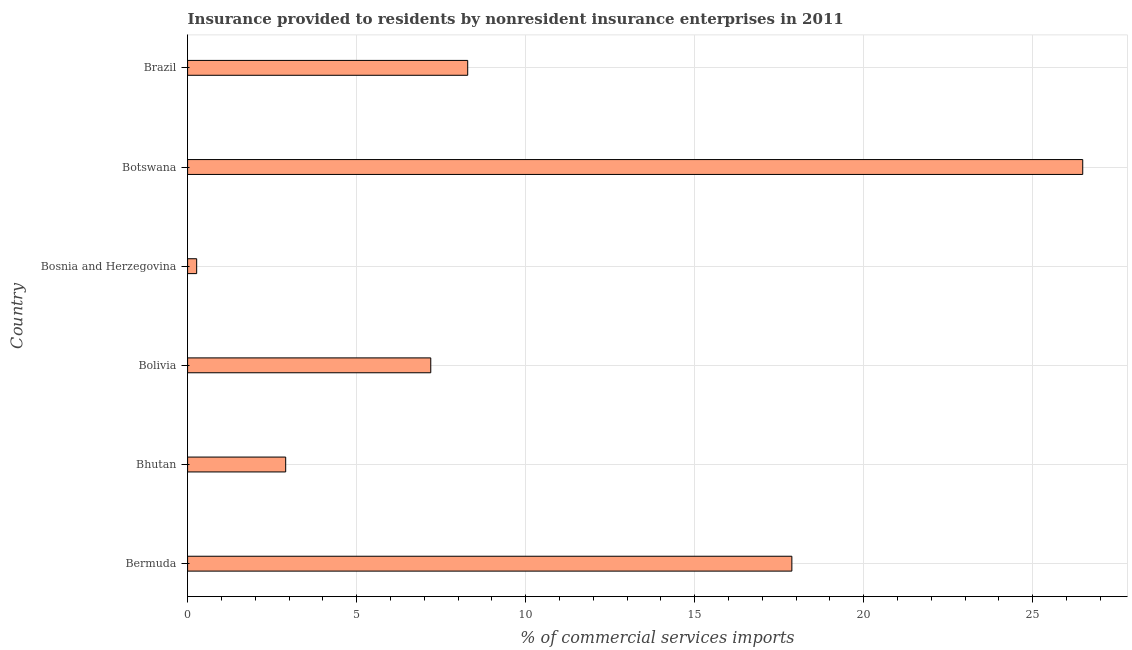Does the graph contain grids?
Your response must be concise. Yes. What is the title of the graph?
Offer a very short reply. Insurance provided to residents by nonresident insurance enterprises in 2011. What is the label or title of the X-axis?
Provide a succinct answer. % of commercial services imports. What is the label or title of the Y-axis?
Offer a terse response. Country. What is the insurance provided by non-residents in Bolivia?
Ensure brevity in your answer.  7.19. Across all countries, what is the maximum insurance provided by non-residents?
Offer a very short reply. 26.48. Across all countries, what is the minimum insurance provided by non-residents?
Make the answer very short. 0.27. In which country was the insurance provided by non-residents maximum?
Your response must be concise. Botswana. In which country was the insurance provided by non-residents minimum?
Ensure brevity in your answer.  Bosnia and Herzegovina. What is the sum of the insurance provided by non-residents?
Give a very brief answer. 63.01. What is the difference between the insurance provided by non-residents in Bhutan and Brazil?
Offer a terse response. -5.38. What is the average insurance provided by non-residents per country?
Your response must be concise. 10.5. What is the median insurance provided by non-residents?
Your answer should be compact. 7.74. In how many countries, is the insurance provided by non-residents greater than 18 %?
Offer a terse response. 1. What is the ratio of the insurance provided by non-residents in Bhutan to that in Brazil?
Give a very brief answer. 0.35. Is the difference between the insurance provided by non-residents in Bosnia and Herzegovina and Botswana greater than the difference between any two countries?
Keep it short and to the point. Yes. What is the difference between the highest and the second highest insurance provided by non-residents?
Make the answer very short. 8.61. What is the difference between the highest and the lowest insurance provided by non-residents?
Keep it short and to the point. 26.21. In how many countries, is the insurance provided by non-residents greater than the average insurance provided by non-residents taken over all countries?
Ensure brevity in your answer.  2. What is the % of commercial services imports in Bermuda?
Provide a short and direct response. 17.88. What is the % of commercial services imports of Bhutan?
Offer a very short reply. 2.9. What is the % of commercial services imports in Bolivia?
Provide a succinct answer. 7.19. What is the % of commercial services imports of Bosnia and Herzegovina?
Keep it short and to the point. 0.27. What is the % of commercial services imports in Botswana?
Offer a very short reply. 26.48. What is the % of commercial services imports of Brazil?
Ensure brevity in your answer.  8.29. What is the difference between the % of commercial services imports in Bermuda and Bhutan?
Your response must be concise. 14.98. What is the difference between the % of commercial services imports in Bermuda and Bolivia?
Ensure brevity in your answer.  10.68. What is the difference between the % of commercial services imports in Bermuda and Bosnia and Herzegovina?
Offer a very short reply. 17.61. What is the difference between the % of commercial services imports in Bermuda and Botswana?
Offer a terse response. -8.61. What is the difference between the % of commercial services imports in Bermuda and Brazil?
Keep it short and to the point. 9.59. What is the difference between the % of commercial services imports in Bhutan and Bolivia?
Ensure brevity in your answer.  -4.29. What is the difference between the % of commercial services imports in Bhutan and Bosnia and Herzegovina?
Keep it short and to the point. 2.63. What is the difference between the % of commercial services imports in Bhutan and Botswana?
Keep it short and to the point. -23.58. What is the difference between the % of commercial services imports in Bhutan and Brazil?
Give a very brief answer. -5.39. What is the difference between the % of commercial services imports in Bolivia and Bosnia and Herzegovina?
Provide a short and direct response. 6.93. What is the difference between the % of commercial services imports in Bolivia and Botswana?
Offer a terse response. -19.29. What is the difference between the % of commercial services imports in Bolivia and Brazil?
Your answer should be very brief. -1.09. What is the difference between the % of commercial services imports in Bosnia and Herzegovina and Botswana?
Your answer should be very brief. -26.21. What is the difference between the % of commercial services imports in Bosnia and Herzegovina and Brazil?
Your answer should be compact. -8.02. What is the difference between the % of commercial services imports in Botswana and Brazil?
Your response must be concise. 18.2. What is the ratio of the % of commercial services imports in Bermuda to that in Bhutan?
Provide a succinct answer. 6.16. What is the ratio of the % of commercial services imports in Bermuda to that in Bolivia?
Keep it short and to the point. 2.48. What is the ratio of the % of commercial services imports in Bermuda to that in Bosnia and Herzegovina?
Provide a succinct answer. 66.53. What is the ratio of the % of commercial services imports in Bermuda to that in Botswana?
Your answer should be compact. 0.68. What is the ratio of the % of commercial services imports in Bermuda to that in Brazil?
Provide a succinct answer. 2.16. What is the ratio of the % of commercial services imports in Bhutan to that in Bolivia?
Keep it short and to the point. 0.4. What is the ratio of the % of commercial services imports in Bhutan to that in Bosnia and Herzegovina?
Your response must be concise. 10.8. What is the ratio of the % of commercial services imports in Bhutan to that in Botswana?
Make the answer very short. 0.11. What is the ratio of the % of commercial services imports in Bhutan to that in Brazil?
Offer a very short reply. 0.35. What is the ratio of the % of commercial services imports in Bolivia to that in Bosnia and Herzegovina?
Ensure brevity in your answer.  26.77. What is the ratio of the % of commercial services imports in Bolivia to that in Botswana?
Make the answer very short. 0.27. What is the ratio of the % of commercial services imports in Bolivia to that in Brazil?
Give a very brief answer. 0.87. What is the ratio of the % of commercial services imports in Bosnia and Herzegovina to that in Botswana?
Your answer should be very brief. 0.01. What is the ratio of the % of commercial services imports in Bosnia and Herzegovina to that in Brazil?
Ensure brevity in your answer.  0.03. What is the ratio of the % of commercial services imports in Botswana to that in Brazil?
Your response must be concise. 3.2. 